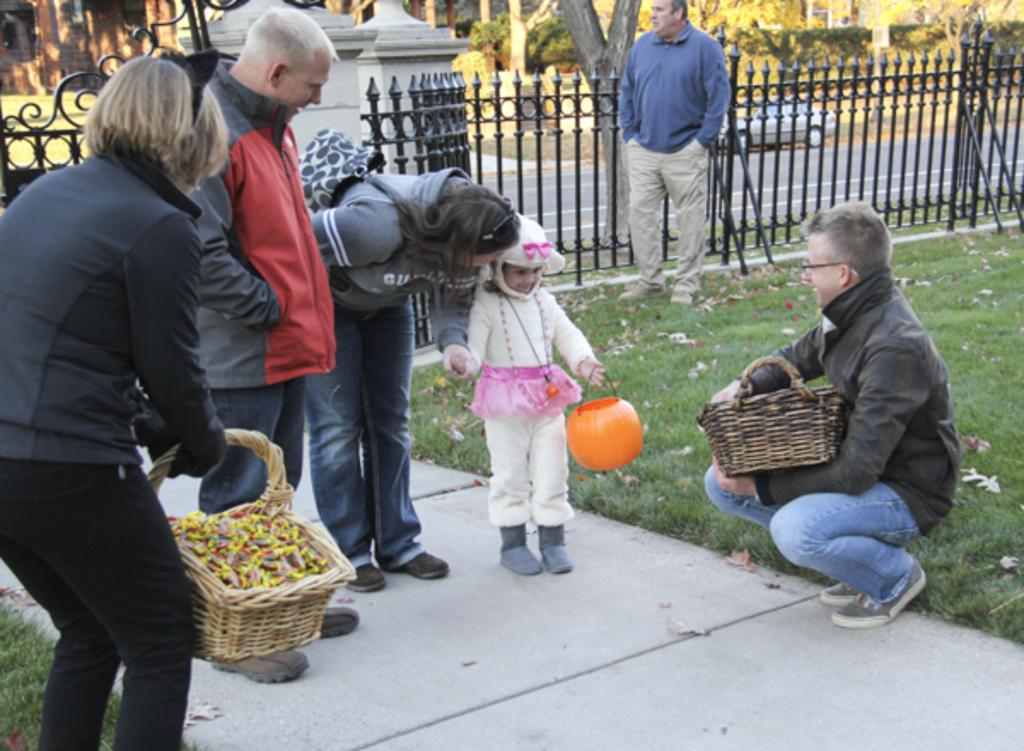What is happening on the ground in the image? There are people on the ground in the image. What objects can be seen in the image? There are baskets visible in the image. What else is present in the image besides people and baskets? There are objects present in the image. What can be seen in the background of the image? There is a fence, a car, and trees in the background of the image. Can you see a picture of a wound on one of the people in the image? There is no picture of a wound present in the image. What type of tool is being used by the people in the image? There is no tool, such as a hammer, visible in the image. 